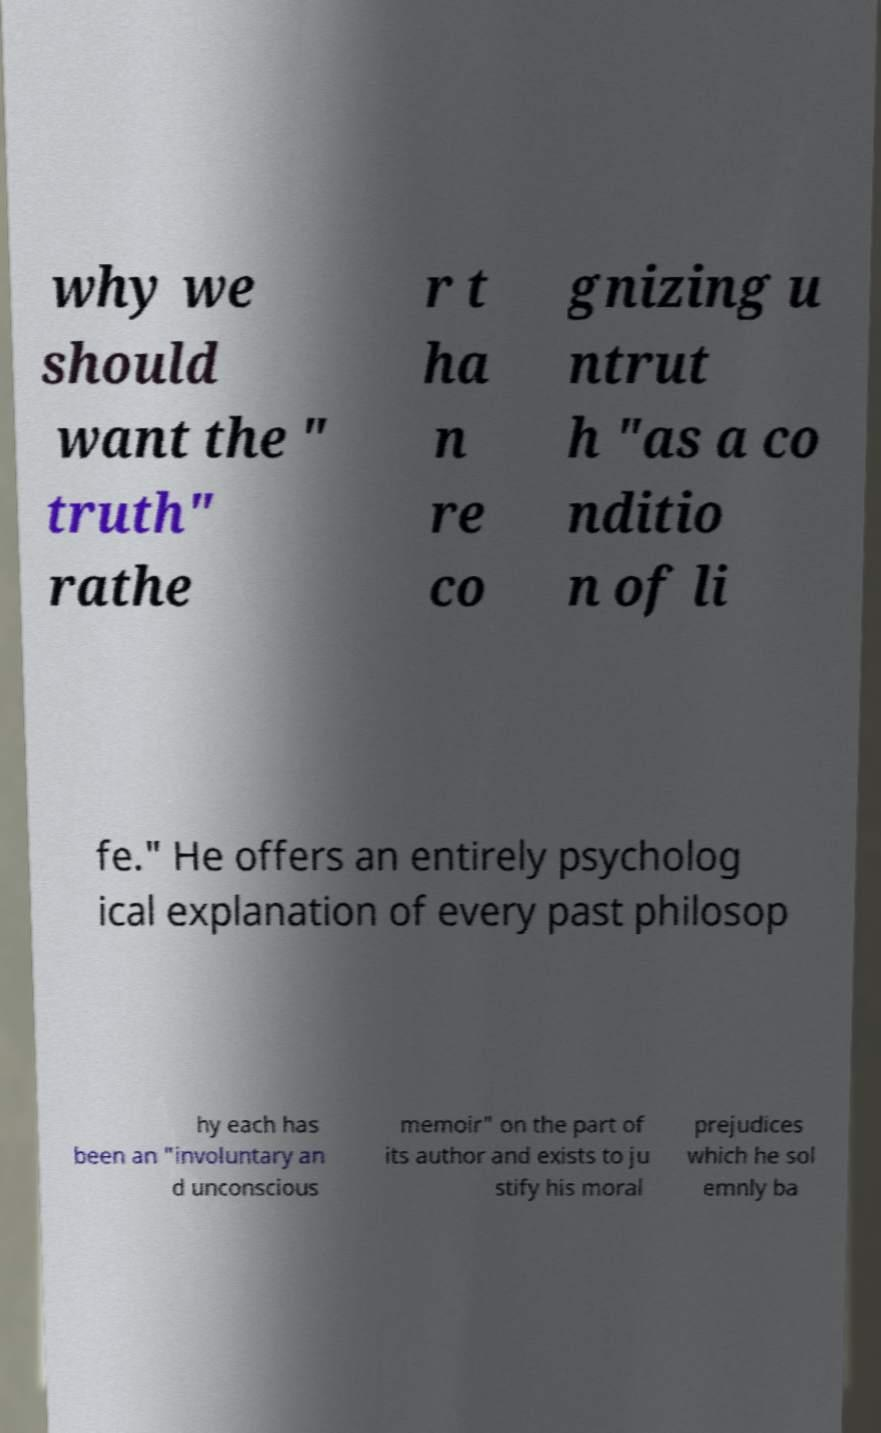I need the written content from this picture converted into text. Can you do that? why we should want the " truth" rathe r t ha n re co gnizing u ntrut h "as a co nditio n of li fe." He offers an entirely psycholog ical explanation of every past philosop hy each has been an "involuntary an d unconscious memoir" on the part of its author and exists to ju stify his moral prejudices which he sol emnly ba 